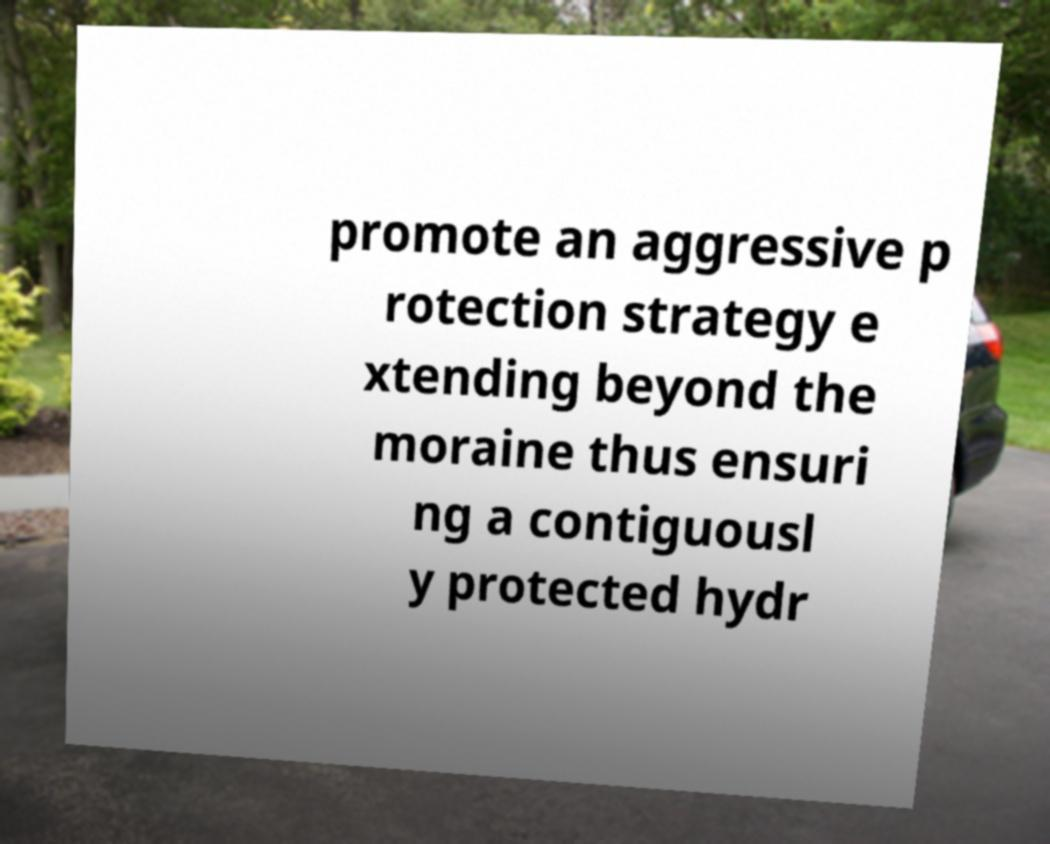For documentation purposes, I need the text within this image transcribed. Could you provide that? promote an aggressive p rotection strategy e xtending beyond the moraine thus ensuri ng a contiguousl y protected hydr 